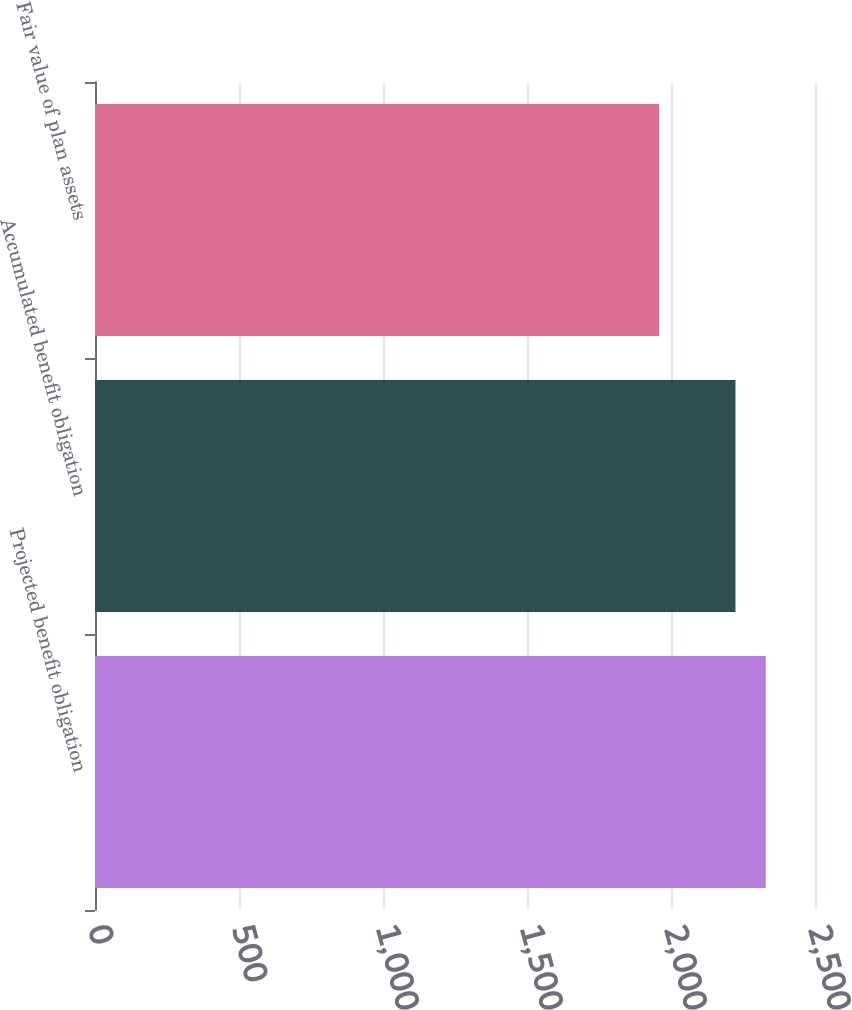Convert chart to OTSL. <chart><loc_0><loc_0><loc_500><loc_500><bar_chart><fcel>Projected benefit obligation<fcel>Accumulated benefit obligation<fcel>Fair value of plan assets<nl><fcel>2329.2<fcel>2223.9<fcel>1958.8<nl></chart> 